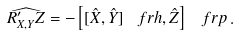<formula> <loc_0><loc_0><loc_500><loc_500>\widehat { R ^ { \prime } _ { X , Y } Z } = - \left [ [ \hat { X } , \hat { Y } ] _ { \ } f r h , \hat { Z } \right ] _ { \ } f r p \, .</formula> 